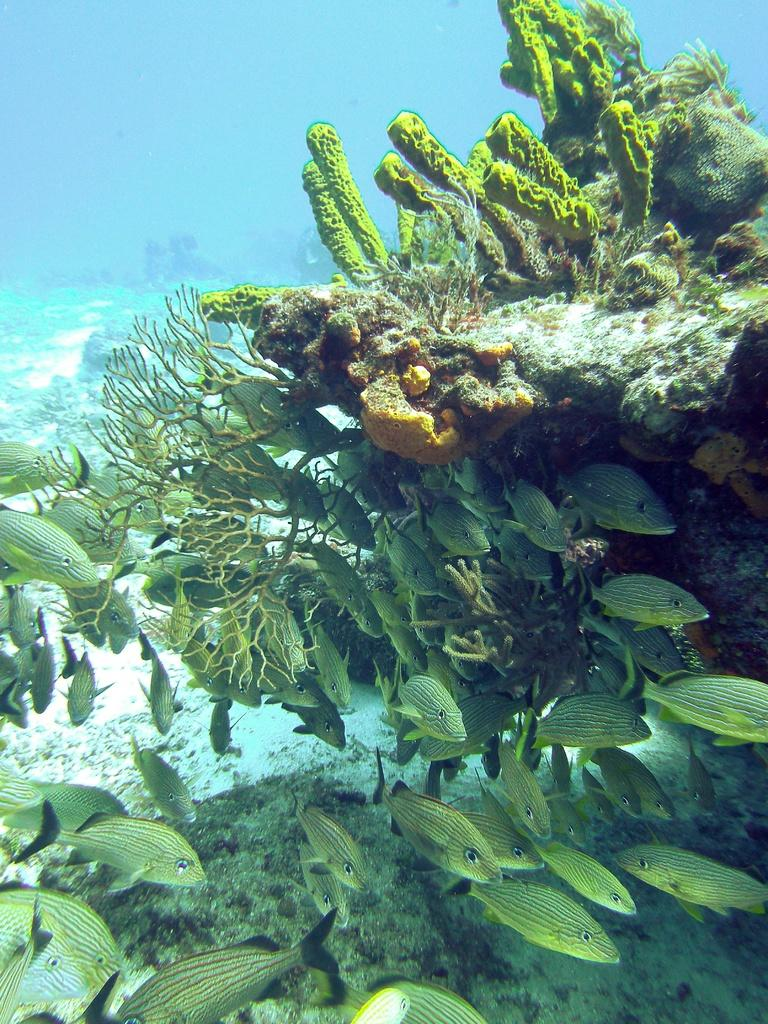What can be seen in the foreground of the image? There are fishes and submarine plants in the foreground of the image. Where was the image taken? The image was taken under the ocean. What type of plants are present in the foreground of the image? The plants in the foreground are submarine plants. What type of straw is used to decorate the hair of the pear in the image? There is no straw, pear, or hair present in the image; it features fishes and submarine plants under the ocean. 